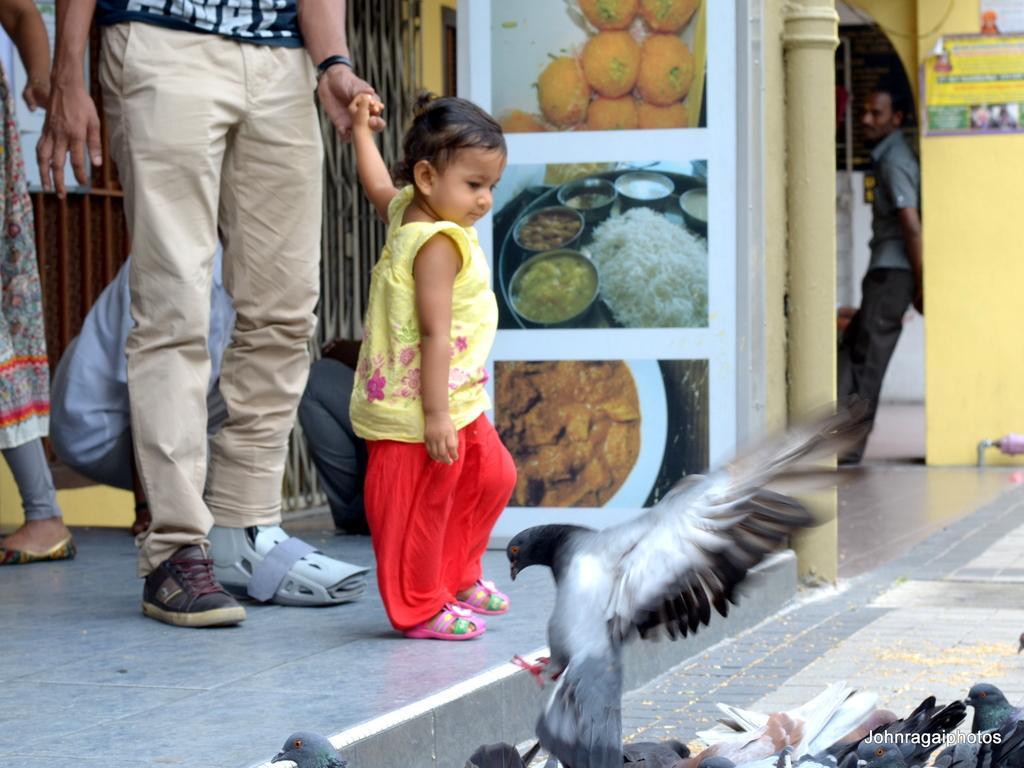How would you summarize this image in a sentence or two? There are some people. Also there are birds. In the back there is a grill. Also there are posters on the wall. And there is a pillar. 